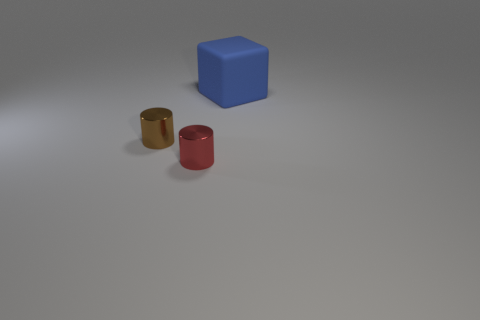There is a cylinder that is in front of the metal thing left of the red metal cylinder; what is it made of?
Your answer should be very brief. Metal. Is the color of the metallic cylinder that is behind the small red cylinder the same as the big rubber object?
Ensure brevity in your answer.  No. Is there any other thing that has the same material as the big blue object?
Ensure brevity in your answer.  No. What number of other objects have the same shape as the red thing?
Offer a terse response. 1. What is the size of the other cylinder that is made of the same material as the tiny brown cylinder?
Ensure brevity in your answer.  Small. There is a blue rubber object that is on the right side of the cylinder that is in front of the tiny brown thing; is there a rubber object that is on the right side of it?
Offer a very short reply. No. Do the cylinder that is on the right side of the brown cylinder and the brown cylinder have the same size?
Offer a terse response. Yes. How many other shiny objects are the same size as the red thing?
Your answer should be compact. 1. The big matte thing is what shape?
Your answer should be very brief. Cube. Are there any tiny rubber cylinders of the same color as the matte object?
Provide a succinct answer. No. 